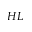<formula> <loc_0><loc_0><loc_500><loc_500>H L</formula> 